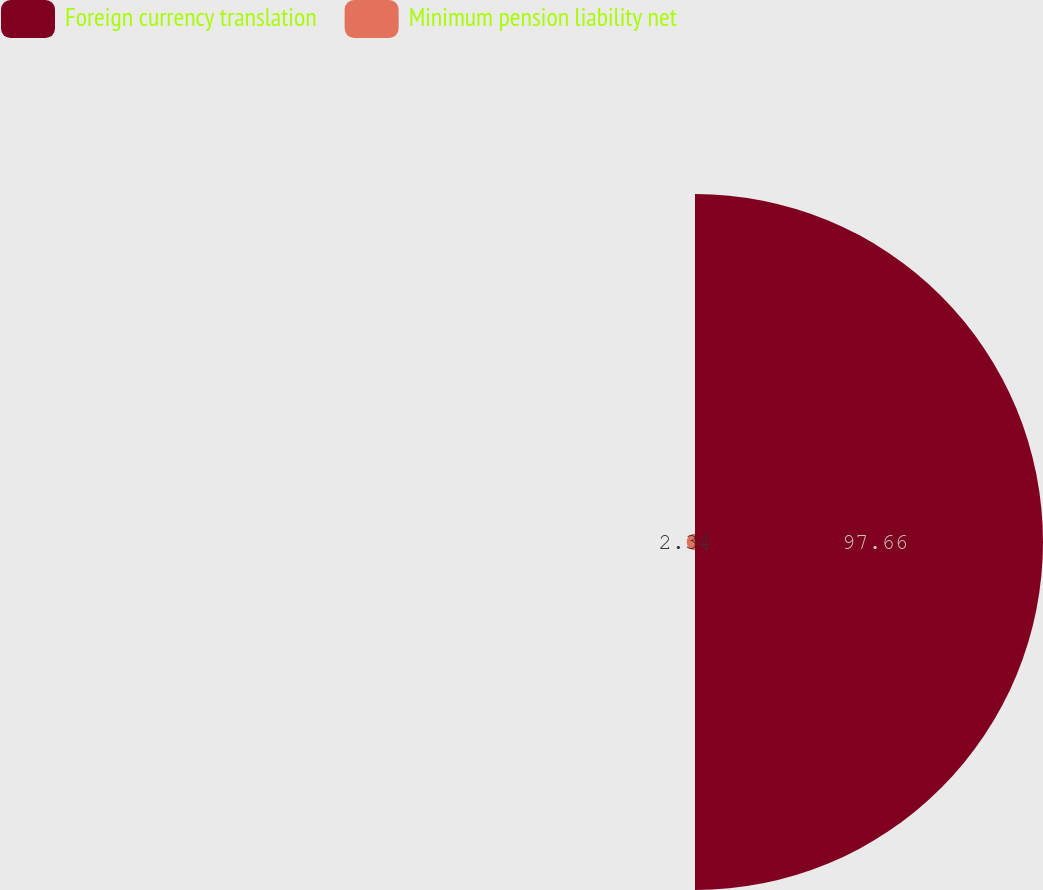Convert chart to OTSL. <chart><loc_0><loc_0><loc_500><loc_500><pie_chart><fcel>Foreign currency translation<fcel>Minimum pension liability net<nl><fcel>97.66%<fcel>2.34%<nl></chart> 